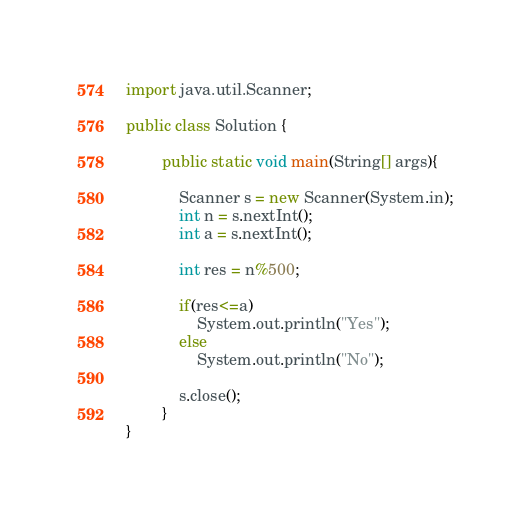Convert code to text. <code><loc_0><loc_0><loc_500><loc_500><_Java_>import java.util.Scanner;

public class Solution {
	
		public static void main(String[] args){
			
			Scanner s = new Scanner(System.in);
			int n = s.nextInt();
			int a = s.nextInt();
			
			int res = n%500;
			
			if(res<=a)
				System.out.println("Yes");
			else
				System.out.println("No");	
			
			s.close();
		}		
}</code> 